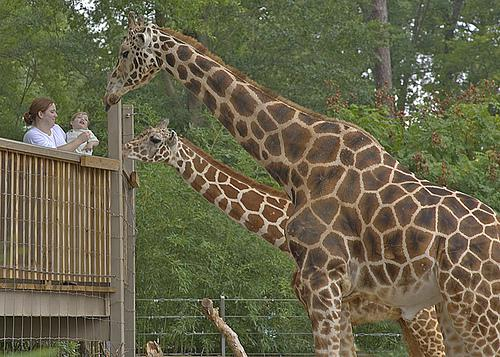Question: what is the focus?
Choices:
A. The rising sun.
B. Getting the project done.
C. Giraffes at the zoo.
D. The telescope.
Answer with the letter. Answer: C Question: how many giraffes are shown standing?
Choices:
A. 3.
B. 4.
C. 2.
D. 5.
Answer with the letter. Answer: C Question: what color are the animals spots?
Choices:
A. Brown.
B. Black.
C. White.
D. Grey.
Answer with the letter. Answer: A 